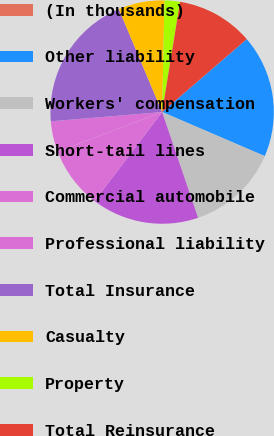Convert chart to OTSL. <chart><loc_0><loc_0><loc_500><loc_500><pie_chart><fcel>(In thousands)<fcel>Other liability<fcel>Workers' compensation<fcel>Short-tail lines<fcel>Commercial automobile<fcel>Professional liability<fcel>Total Insurance<fcel>Casualty<fcel>Property<fcel>Total Reinsurance<nl><fcel>0.01%<fcel>17.77%<fcel>13.33%<fcel>15.55%<fcel>8.89%<fcel>4.45%<fcel>19.99%<fcel>6.67%<fcel>2.23%<fcel>11.11%<nl></chart> 